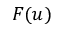Convert formula to latex. <formula><loc_0><loc_0><loc_500><loc_500>F ( u )</formula> 